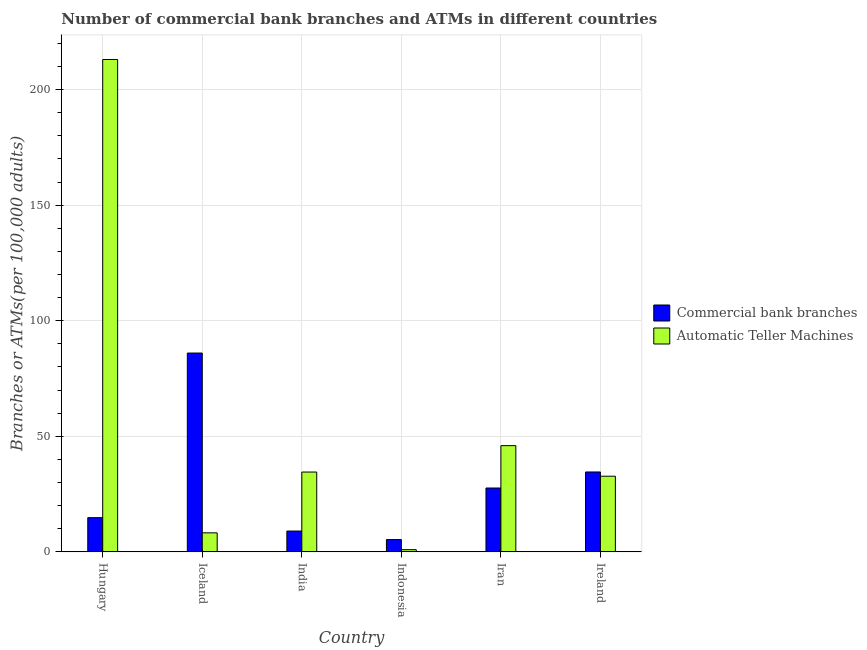How many different coloured bars are there?
Offer a very short reply. 2. How many groups of bars are there?
Give a very brief answer. 6. Are the number of bars per tick equal to the number of legend labels?
Your response must be concise. Yes. How many bars are there on the 5th tick from the left?
Your response must be concise. 2. How many bars are there on the 2nd tick from the right?
Make the answer very short. 2. What is the label of the 1st group of bars from the left?
Your response must be concise. Hungary. What is the number of atms in Indonesia?
Keep it short and to the point. 0.96. Across all countries, what is the maximum number of atms?
Offer a very short reply. 213.05. Across all countries, what is the minimum number of atms?
Keep it short and to the point. 0.96. In which country was the number of atms maximum?
Offer a very short reply. Hungary. In which country was the number of commercal bank branches minimum?
Offer a very short reply. Indonesia. What is the total number of commercal bank branches in the graph?
Offer a very short reply. 177.39. What is the difference between the number of commercal bank branches in Hungary and that in Iran?
Your response must be concise. -12.83. What is the difference between the number of commercal bank branches in Iran and the number of atms in Iceland?
Offer a terse response. 19.4. What is the average number of commercal bank branches per country?
Your answer should be very brief. 29.57. What is the difference between the number of commercal bank branches and number of atms in Iran?
Provide a succinct answer. -18.32. What is the ratio of the number of atms in India to that in Ireland?
Offer a very short reply. 1.06. Is the number of atms in India less than that in Iran?
Offer a terse response. Yes. Is the difference between the number of commercal bank branches in Indonesia and Iran greater than the difference between the number of atms in Indonesia and Iran?
Your answer should be compact. Yes. What is the difference between the highest and the second highest number of atms?
Ensure brevity in your answer.  167.09. What is the difference between the highest and the lowest number of atms?
Offer a terse response. 212.09. In how many countries, is the number of atms greater than the average number of atms taken over all countries?
Offer a terse response. 1. What does the 1st bar from the left in India represents?
Provide a succinct answer. Commercial bank branches. What does the 1st bar from the right in Ireland represents?
Offer a very short reply. Automatic Teller Machines. How many countries are there in the graph?
Offer a terse response. 6. What is the difference between two consecutive major ticks on the Y-axis?
Your answer should be very brief. 50. Does the graph contain any zero values?
Keep it short and to the point. No. What is the title of the graph?
Give a very brief answer. Number of commercial bank branches and ATMs in different countries. What is the label or title of the X-axis?
Make the answer very short. Country. What is the label or title of the Y-axis?
Ensure brevity in your answer.  Branches or ATMs(per 100,0 adults). What is the Branches or ATMs(per 100,000 adults) of Commercial bank branches in Hungary?
Your answer should be very brief. 14.81. What is the Branches or ATMs(per 100,000 adults) in Automatic Teller Machines in Hungary?
Offer a very short reply. 213.05. What is the Branches or ATMs(per 100,000 adults) in Commercial bank branches in Iceland?
Your response must be concise. 86.04. What is the Branches or ATMs(per 100,000 adults) in Automatic Teller Machines in Iceland?
Make the answer very short. 8.24. What is the Branches or ATMs(per 100,000 adults) of Commercial bank branches in India?
Your answer should be compact. 9.02. What is the Branches or ATMs(per 100,000 adults) in Automatic Teller Machines in India?
Provide a succinct answer. 34.55. What is the Branches or ATMs(per 100,000 adults) of Commercial bank branches in Indonesia?
Keep it short and to the point. 5.32. What is the Branches or ATMs(per 100,000 adults) in Automatic Teller Machines in Indonesia?
Your response must be concise. 0.96. What is the Branches or ATMs(per 100,000 adults) in Commercial bank branches in Iran?
Offer a terse response. 27.64. What is the Branches or ATMs(per 100,000 adults) in Automatic Teller Machines in Iran?
Make the answer very short. 45.96. What is the Branches or ATMs(per 100,000 adults) in Commercial bank branches in Ireland?
Ensure brevity in your answer.  34.57. What is the Branches or ATMs(per 100,000 adults) of Automatic Teller Machines in Ireland?
Keep it short and to the point. 32.74. Across all countries, what is the maximum Branches or ATMs(per 100,000 adults) of Commercial bank branches?
Make the answer very short. 86.04. Across all countries, what is the maximum Branches or ATMs(per 100,000 adults) in Automatic Teller Machines?
Your answer should be very brief. 213.05. Across all countries, what is the minimum Branches or ATMs(per 100,000 adults) of Commercial bank branches?
Offer a very short reply. 5.32. Across all countries, what is the minimum Branches or ATMs(per 100,000 adults) of Automatic Teller Machines?
Provide a succinct answer. 0.96. What is the total Branches or ATMs(per 100,000 adults) of Commercial bank branches in the graph?
Offer a very short reply. 177.39. What is the total Branches or ATMs(per 100,000 adults) in Automatic Teller Machines in the graph?
Your response must be concise. 335.5. What is the difference between the Branches or ATMs(per 100,000 adults) of Commercial bank branches in Hungary and that in Iceland?
Provide a short and direct response. -71.23. What is the difference between the Branches or ATMs(per 100,000 adults) in Automatic Teller Machines in Hungary and that in Iceland?
Make the answer very short. 204.81. What is the difference between the Branches or ATMs(per 100,000 adults) of Commercial bank branches in Hungary and that in India?
Your answer should be very brief. 5.79. What is the difference between the Branches or ATMs(per 100,000 adults) of Automatic Teller Machines in Hungary and that in India?
Ensure brevity in your answer.  178.51. What is the difference between the Branches or ATMs(per 100,000 adults) in Commercial bank branches in Hungary and that in Indonesia?
Offer a terse response. 9.48. What is the difference between the Branches or ATMs(per 100,000 adults) of Automatic Teller Machines in Hungary and that in Indonesia?
Your response must be concise. 212.09. What is the difference between the Branches or ATMs(per 100,000 adults) in Commercial bank branches in Hungary and that in Iran?
Offer a terse response. -12.83. What is the difference between the Branches or ATMs(per 100,000 adults) in Automatic Teller Machines in Hungary and that in Iran?
Keep it short and to the point. 167.09. What is the difference between the Branches or ATMs(per 100,000 adults) in Commercial bank branches in Hungary and that in Ireland?
Your answer should be very brief. -19.76. What is the difference between the Branches or ATMs(per 100,000 adults) in Automatic Teller Machines in Hungary and that in Ireland?
Provide a succinct answer. 180.31. What is the difference between the Branches or ATMs(per 100,000 adults) of Commercial bank branches in Iceland and that in India?
Offer a terse response. 77.02. What is the difference between the Branches or ATMs(per 100,000 adults) of Automatic Teller Machines in Iceland and that in India?
Give a very brief answer. -26.31. What is the difference between the Branches or ATMs(per 100,000 adults) of Commercial bank branches in Iceland and that in Indonesia?
Your answer should be compact. 80.71. What is the difference between the Branches or ATMs(per 100,000 adults) of Automatic Teller Machines in Iceland and that in Indonesia?
Keep it short and to the point. 7.28. What is the difference between the Branches or ATMs(per 100,000 adults) in Commercial bank branches in Iceland and that in Iran?
Offer a very short reply. 58.4. What is the difference between the Branches or ATMs(per 100,000 adults) of Automatic Teller Machines in Iceland and that in Iran?
Provide a succinct answer. -37.72. What is the difference between the Branches or ATMs(per 100,000 adults) in Commercial bank branches in Iceland and that in Ireland?
Keep it short and to the point. 51.47. What is the difference between the Branches or ATMs(per 100,000 adults) in Automatic Teller Machines in Iceland and that in Ireland?
Your answer should be compact. -24.5. What is the difference between the Branches or ATMs(per 100,000 adults) in Commercial bank branches in India and that in Indonesia?
Your response must be concise. 3.69. What is the difference between the Branches or ATMs(per 100,000 adults) of Automatic Teller Machines in India and that in Indonesia?
Offer a terse response. 33.59. What is the difference between the Branches or ATMs(per 100,000 adults) in Commercial bank branches in India and that in Iran?
Make the answer very short. -18.62. What is the difference between the Branches or ATMs(per 100,000 adults) in Automatic Teller Machines in India and that in Iran?
Your response must be concise. -11.41. What is the difference between the Branches or ATMs(per 100,000 adults) of Commercial bank branches in India and that in Ireland?
Offer a terse response. -25.55. What is the difference between the Branches or ATMs(per 100,000 adults) in Automatic Teller Machines in India and that in Ireland?
Your answer should be compact. 1.81. What is the difference between the Branches or ATMs(per 100,000 adults) in Commercial bank branches in Indonesia and that in Iran?
Your answer should be compact. -22.31. What is the difference between the Branches or ATMs(per 100,000 adults) of Automatic Teller Machines in Indonesia and that in Iran?
Keep it short and to the point. -45. What is the difference between the Branches or ATMs(per 100,000 adults) of Commercial bank branches in Indonesia and that in Ireland?
Provide a succinct answer. -29.24. What is the difference between the Branches or ATMs(per 100,000 adults) in Automatic Teller Machines in Indonesia and that in Ireland?
Give a very brief answer. -31.78. What is the difference between the Branches or ATMs(per 100,000 adults) of Commercial bank branches in Iran and that in Ireland?
Your response must be concise. -6.93. What is the difference between the Branches or ATMs(per 100,000 adults) of Automatic Teller Machines in Iran and that in Ireland?
Offer a very short reply. 13.22. What is the difference between the Branches or ATMs(per 100,000 adults) in Commercial bank branches in Hungary and the Branches or ATMs(per 100,000 adults) in Automatic Teller Machines in Iceland?
Offer a terse response. 6.57. What is the difference between the Branches or ATMs(per 100,000 adults) of Commercial bank branches in Hungary and the Branches or ATMs(per 100,000 adults) of Automatic Teller Machines in India?
Your response must be concise. -19.74. What is the difference between the Branches or ATMs(per 100,000 adults) in Commercial bank branches in Hungary and the Branches or ATMs(per 100,000 adults) in Automatic Teller Machines in Indonesia?
Your answer should be very brief. 13.85. What is the difference between the Branches or ATMs(per 100,000 adults) of Commercial bank branches in Hungary and the Branches or ATMs(per 100,000 adults) of Automatic Teller Machines in Iran?
Provide a short and direct response. -31.15. What is the difference between the Branches or ATMs(per 100,000 adults) of Commercial bank branches in Hungary and the Branches or ATMs(per 100,000 adults) of Automatic Teller Machines in Ireland?
Your response must be concise. -17.93. What is the difference between the Branches or ATMs(per 100,000 adults) of Commercial bank branches in Iceland and the Branches or ATMs(per 100,000 adults) of Automatic Teller Machines in India?
Provide a short and direct response. 51.49. What is the difference between the Branches or ATMs(per 100,000 adults) of Commercial bank branches in Iceland and the Branches or ATMs(per 100,000 adults) of Automatic Teller Machines in Indonesia?
Ensure brevity in your answer.  85.08. What is the difference between the Branches or ATMs(per 100,000 adults) in Commercial bank branches in Iceland and the Branches or ATMs(per 100,000 adults) in Automatic Teller Machines in Iran?
Offer a very short reply. 40.08. What is the difference between the Branches or ATMs(per 100,000 adults) in Commercial bank branches in Iceland and the Branches or ATMs(per 100,000 adults) in Automatic Teller Machines in Ireland?
Give a very brief answer. 53.3. What is the difference between the Branches or ATMs(per 100,000 adults) of Commercial bank branches in India and the Branches or ATMs(per 100,000 adults) of Automatic Teller Machines in Indonesia?
Give a very brief answer. 8.06. What is the difference between the Branches or ATMs(per 100,000 adults) in Commercial bank branches in India and the Branches or ATMs(per 100,000 adults) in Automatic Teller Machines in Iran?
Your answer should be compact. -36.94. What is the difference between the Branches or ATMs(per 100,000 adults) of Commercial bank branches in India and the Branches or ATMs(per 100,000 adults) of Automatic Teller Machines in Ireland?
Provide a short and direct response. -23.72. What is the difference between the Branches or ATMs(per 100,000 adults) in Commercial bank branches in Indonesia and the Branches or ATMs(per 100,000 adults) in Automatic Teller Machines in Iran?
Offer a very short reply. -40.64. What is the difference between the Branches or ATMs(per 100,000 adults) in Commercial bank branches in Indonesia and the Branches or ATMs(per 100,000 adults) in Automatic Teller Machines in Ireland?
Ensure brevity in your answer.  -27.41. What is the difference between the Branches or ATMs(per 100,000 adults) of Commercial bank branches in Iran and the Branches or ATMs(per 100,000 adults) of Automatic Teller Machines in Ireland?
Your answer should be very brief. -5.1. What is the average Branches or ATMs(per 100,000 adults) of Commercial bank branches per country?
Your answer should be compact. 29.57. What is the average Branches or ATMs(per 100,000 adults) in Automatic Teller Machines per country?
Give a very brief answer. 55.92. What is the difference between the Branches or ATMs(per 100,000 adults) of Commercial bank branches and Branches or ATMs(per 100,000 adults) of Automatic Teller Machines in Hungary?
Your answer should be very brief. -198.25. What is the difference between the Branches or ATMs(per 100,000 adults) in Commercial bank branches and Branches or ATMs(per 100,000 adults) in Automatic Teller Machines in Iceland?
Offer a terse response. 77.8. What is the difference between the Branches or ATMs(per 100,000 adults) of Commercial bank branches and Branches or ATMs(per 100,000 adults) of Automatic Teller Machines in India?
Ensure brevity in your answer.  -25.53. What is the difference between the Branches or ATMs(per 100,000 adults) of Commercial bank branches and Branches or ATMs(per 100,000 adults) of Automatic Teller Machines in Indonesia?
Give a very brief answer. 4.37. What is the difference between the Branches or ATMs(per 100,000 adults) of Commercial bank branches and Branches or ATMs(per 100,000 adults) of Automatic Teller Machines in Iran?
Offer a very short reply. -18.32. What is the difference between the Branches or ATMs(per 100,000 adults) of Commercial bank branches and Branches or ATMs(per 100,000 adults) of Automatic Teller Machines in Ireland?
Ensure brevity in your answer.  1.83. What is the ratio of the Branches or ATMs(per 100,000 adults) of Commercial bank branches in Hungary to that in Iceland?
Your response must be concise. 0.17. What is the ratio of the Branches or ATMs(per 100,000 adults) of Automatic Teller Machines in Hungary to that in Iceland?
Your response must be concise. 25.86. What is the ratio of the Branches or ATMs(per 100,000 adults) of Commercial bank branches in Hungary to that in India?
Your response must be concise. 1.64. What is the ratio of the Branches or ATMs(per 100,000 adults) of Automatic Teller Machines in Hungary to that in India?
Ensure brevity in your answer.  6.17. What is the ratio of the Branches or ATMs(per 100,000 adults) of Commercial bank branches in Hungary to that in Indonesia?
Provide a short and direct response. 2.78. What is the ratio of the Branches or ATMs(per 100,000 adults) of Automatic Teller Machines in Hungary to that in Indonesia?
Your answer should be compact. 222.34. What is the ratio of the Branches or ATMs(per 100,000 adults) in Commercial bank branches in Hungary to that in Iran?
Ensure brevity in your answer.  0.54. What is the ratio of the Branches or ATMs(per 100,000 adults) of Automatic Teller Machines in Hungary to that in Iran?
Provide a short and direct response. 4.64. What is the ratio of the Branches or ATMs(per 100,000 adults) of Commercial bank branches in Hungary to that in Ireland?
Your response must be concise. 0.43. What is the ratio of the Branches or ATMs(per 100,000 adults) of Automatic Teller Machines in Hungary to that in Ireland?
Offer a terse response. 6.51. What is the ratio of the Branches or ATMs(per 100,000 adults) in Commercial bank branches in Iceland to that in India?
Provide a short and direct response. 9.54. What is the ratio of the Branches or ATMs(per 100,000 adults) of Automatic Teller Machines in Iceland to that in India?
Your answer should be very brief. 0.24. What is the ratio of the Branches or ATMs(per 100,000 adults) in Commercial bank branches in Iceland to that in Indonesia?
Give a very brief answer. 16.16. What is the ratio of the Branches or ATMs(per 100,000 adults) of Automatic Teller Machines in Iceland to that in Indonesia?
Your answer should be compact. 8.6. What is the ratio of the Branches or ATMs(per 100,000 adults) in Commercial bank branches in Iceland to that in Iran?
Provide a short and direct response. 3.11. What is the ratio of the Branches or ATMs(per 100,000 adults) in Automatic Teller Machines in Iceland to that in Iran?
Give a very brief answer. 0.18. What is the ratio of the Branches or ATMs(per 100,000 adults) in Commercial bank branches in Iceland to that in Ireland?
Ensure brevity in your answer.  2.49. What is the ratio of the Branches or ATMs(per 100,000 adults) in Automatic Teller Machines in Iceland to that in Ireland?
Ensure brevity in your answer.  0.25. What is the ratio of the Branches or ATMs(per 100,000 adults) in Commercial bank branches in India to that in Indonesia?
Offer a terse response. 1.69. What is the ratio of the Branches or ATMs(per 100,000 adults) of Automatic Teller Machines in India to that in Indonesia?
Make the answer very short. 36.05. What is the ratio of the Branches or ATMs(per 100,000 adults) of Commercial bank branches in India to that in Iran?
Provide a short and direct response. 0.33. What is the ratio of the Branches or ATMs(per 100,000 adults) of Automatic Teller Machines in India to that in Iran?
Your response must be concise. 0.75. What is the ratio of the Branches or ATMs(per 100,000 adults) of Commercial bank branches in India to that in Ireland?
Keep it short and to the point. 0.26. What is the ratio of the Branches or ATMs(per 100,000 adults) in Automatic Teller Machines in India to that in Ireland?
Your answer should be very brief. 1.06. What is the ratio of the Branches or ATMs(per 100,000 adults) of Commercial bank branches in Indonesia to that in Iran?
Keep it short and to the point. 0.19. What is the ratio of the Branches or ATMs(per 100,000 adults) of Automatic Teller Machines in Indonesia to that in Iran?
Make the answer very short. 0.02. What is the ratio of the Branches or ATMs(per 100,000 adults) of Commercial bank branches in Indonesia to that in Ireland?
Make the answer very short. 0.15. What is the ratio of the Branches or ATMs(per 100,000 adults) in Automatic Teller Machines in Indonesia to that in Ireland?
Offer a terse response. 0.03. What is the ratio of the Branches or ATMs(per 100,000 adults) of Commercial bank branches in Iran to that in Ireland?
Offer a very short reply. 0.8. What is the ratio of the Branches or ATMs(per 100,000 adults) in Automatic Teller Machines in Iran to that in Ireland?
Make the answer very short. 1.4. What is the difference between the highest and the second highest Branches or ATMs(per 100,000 adults) of Commercial bank branches?
Keep it short and to the point. 51.47. What is the difference between the highest and the second highest Branches or ATMs(per 100,000 adults) of Automatic Teller Machines?
Give a very brief answer. 167.09. What is the difference between the highest and the lowest Branches or ATMs(per 100,000 adults) in Commercial bank branches?
Keep it short and to the point. 80.71. What is the difference between the highest and the lowest Branches or ATMs(per 100,000 adults) of Automatic Teller Machines?
Your answer should be very brief. 212.09. 